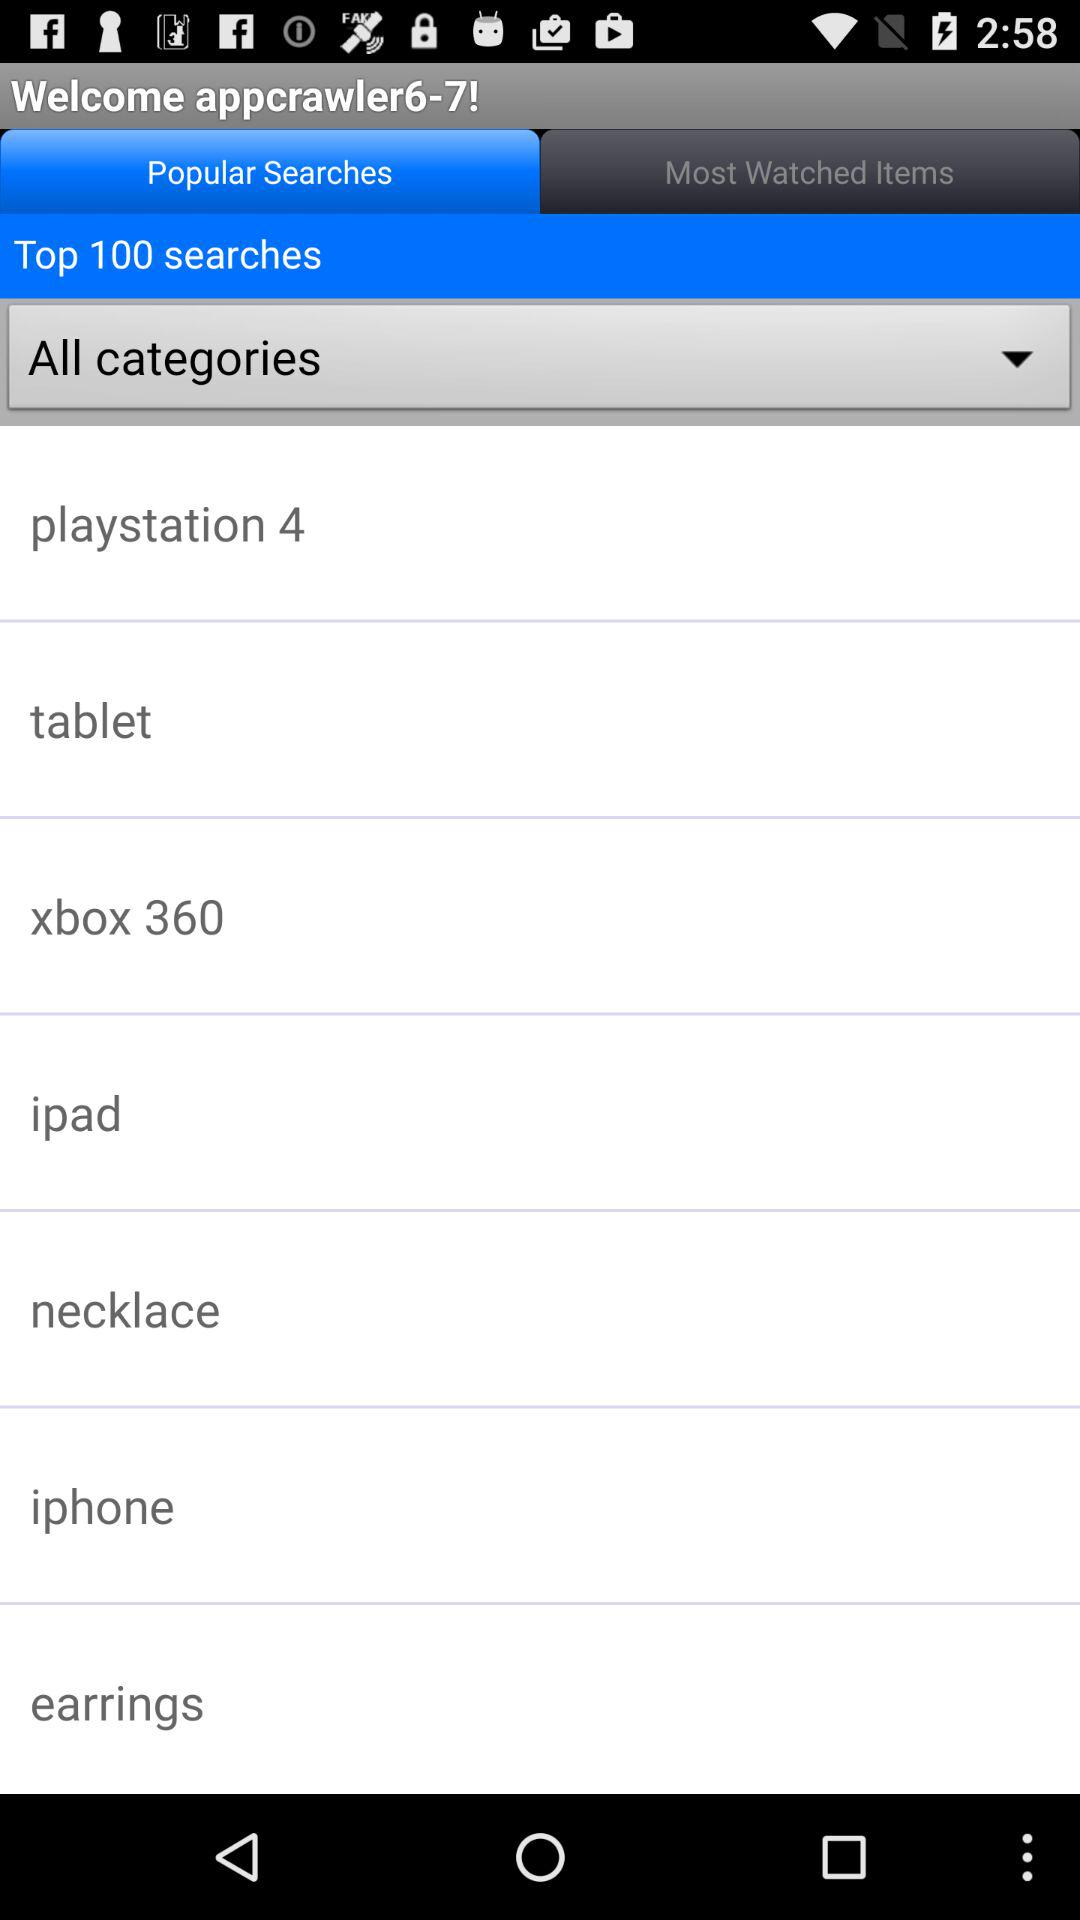What are the different types of categories? The types of categories are "playstation 4", "tablet", "xbox 360", "ipad", "necklace", "iphone", and "earrings". 